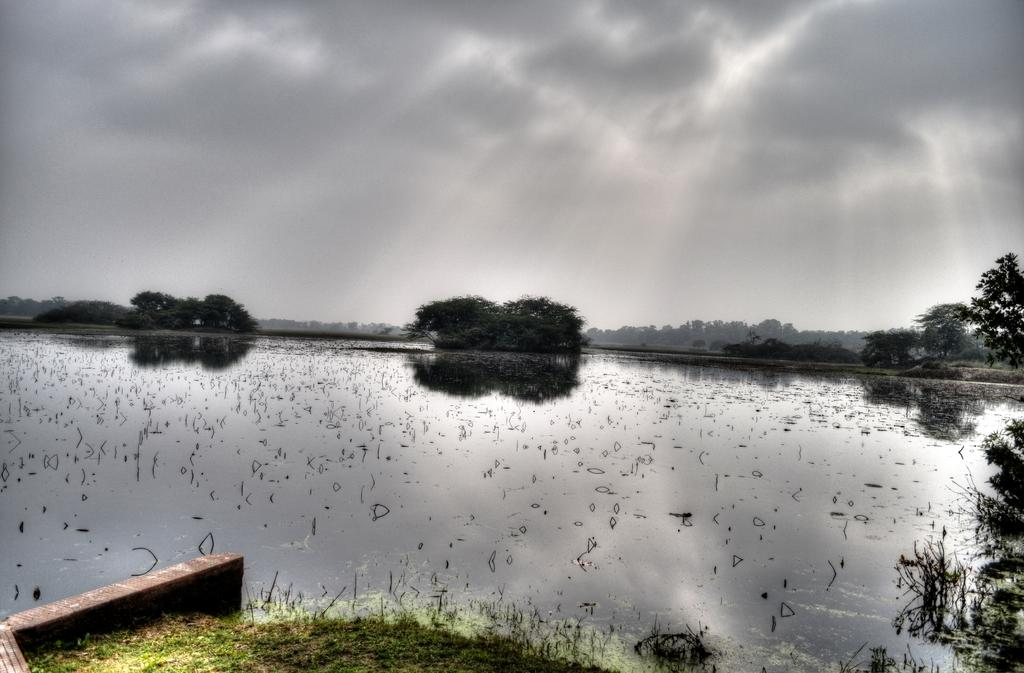What type of vegetation can be seen in the image? There is grass in the image. What natural element is also present in the image? There is water in the image. What other type of vegetation can be seen in the image? There are trees in the image. How would you describe the sky in the background of the image? The sky is cloudy in the background. Despite the cloudy sky, what else can be seen in the background? Sun rays are visible in the background. What type of food is being prepared in the image? There is no food preparation visible in the image; it primarily features natural elements like grass, water, trees, and the sky. 